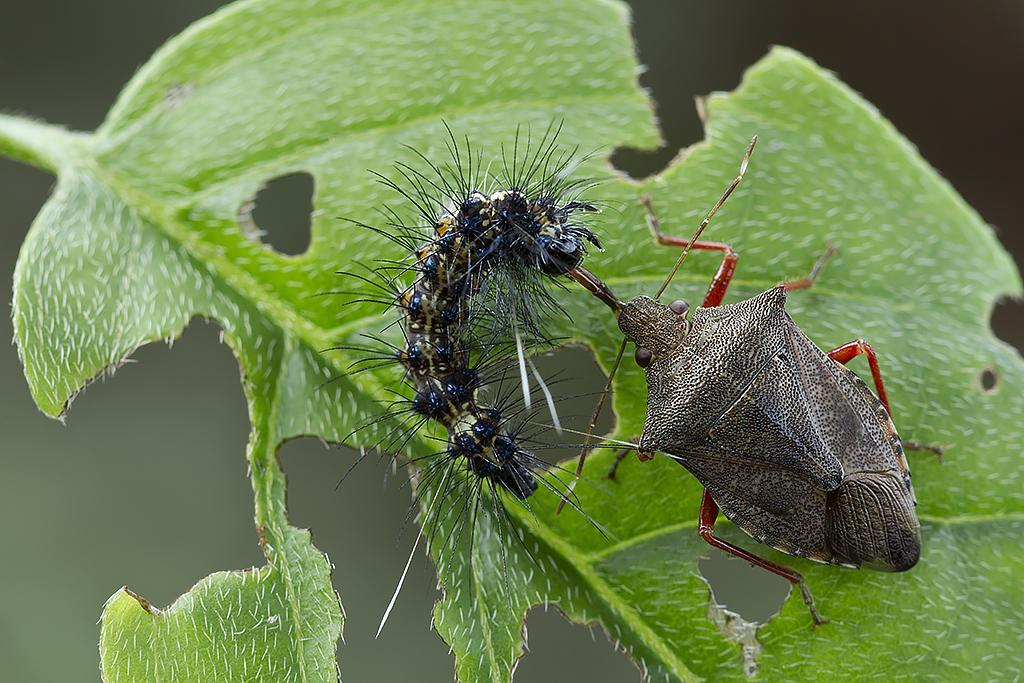Describe this image in one or two sentences. In this image there are insects on the leaf and the background of the image is blur. 